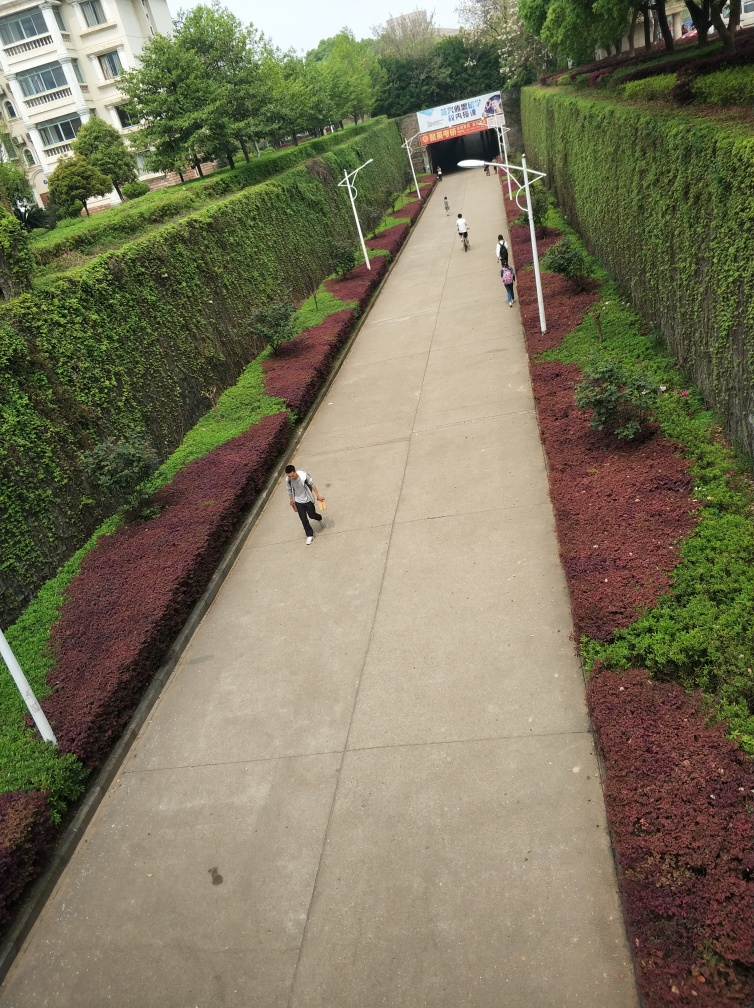What activities are the people in the image engaged in? From the image, we can observe several pedestrians who are likely engaging in everyday activities. One individual in the foreground seems to be walking while using their mobile phone, potentially texting or navigating. Other figures in the image appear to be walking along the pathway, possibly transiting to or from the tunnel in the background. The overall atmosphere suggests a quiet, routine day without any unusual events or activities taking place. 